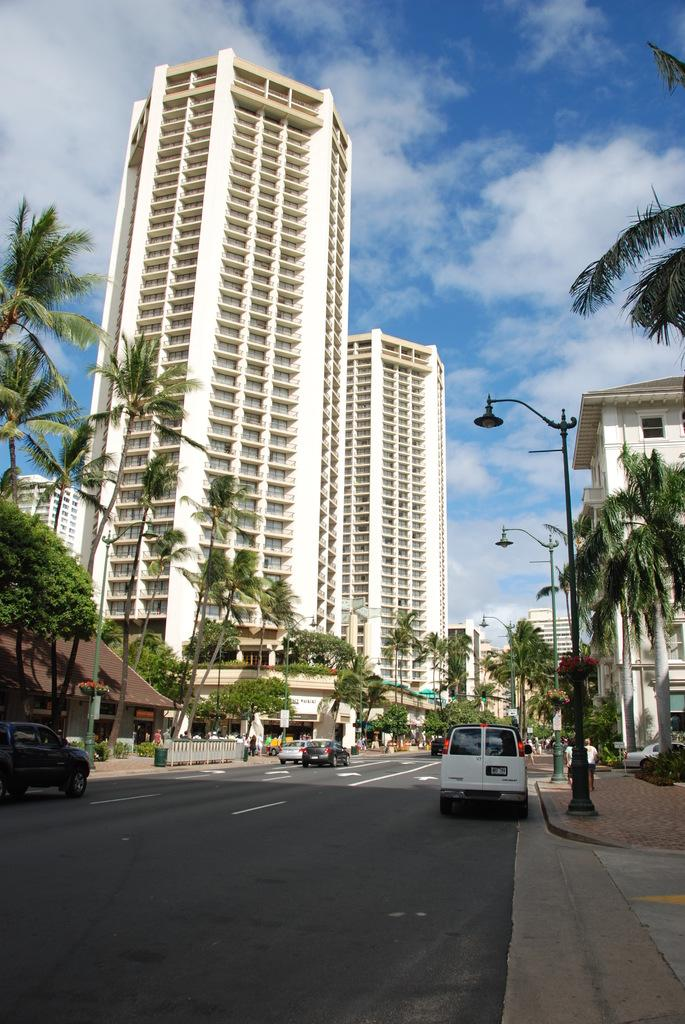What type of structures are present in the image? There are skyscrapers and buildings in the image. What are some other objects visible in the image? Street poles, street lights, motor vehicles, bins, a grill, and trees are present in the image. What is the setting of the image? There is a road in the image, and the sky is visible with clouds. What might be used for illumination at night? Street lights are present in the image for illumination. What invention is being demonstrated by the person in the image? There is no person present in the image, and therefore no invention being demonstrated. What type of vest is the person wearing in the image? There is no person present in the image, and therefore no vest being worn. 